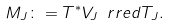Convert formula to latex. <formula><loc_0><loc_0><loc_500><loc_500>M _ { J } \colon = T ^ { \ast } V _ { J } \ r r e d T _ { J } .</formula> 